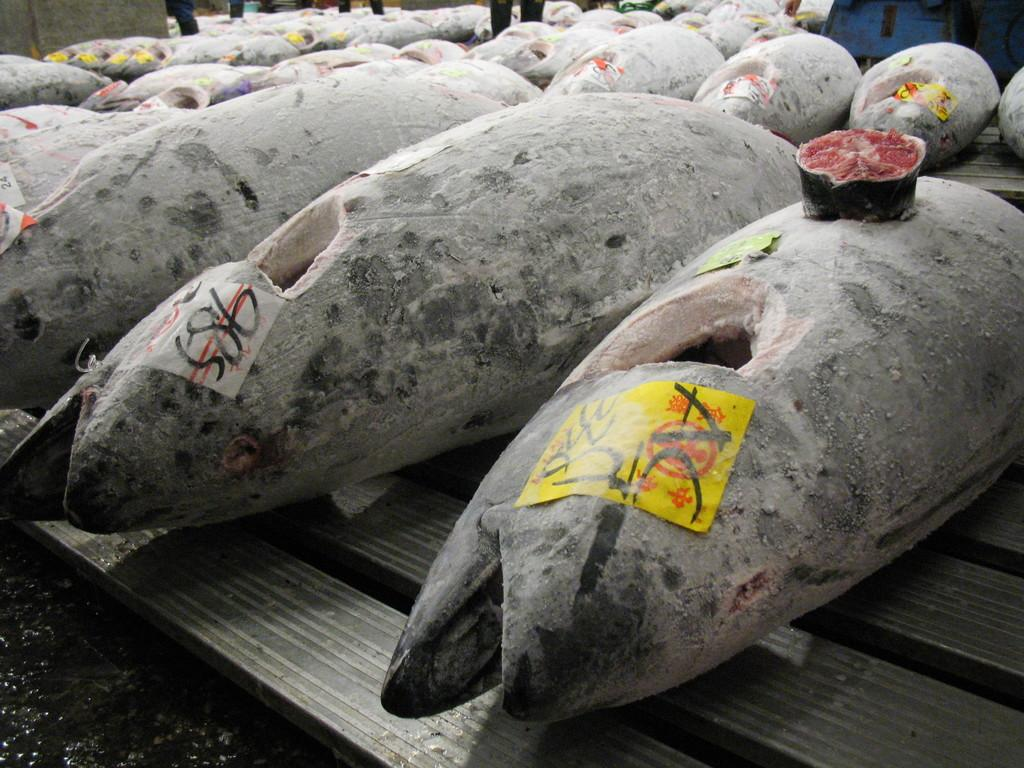What type of animals are featured in the image? There are fish with stickers in the image. Where are the fish located? The fish are on a platform in the image. Can you describe the people in the image? The legs of people are visible at the top of the image. What is present on the right side of the image? There is an object on the right side of the image. What type of square needle is being used by the grandmother in the image? There is no grandmother or needle present in the image. 